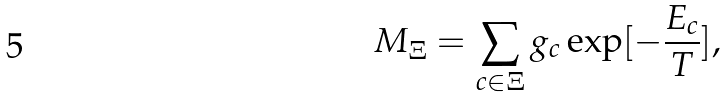<formula> <loc_0><loc_0><loc_500><loc_500>M _ { \Xi } = \sum _ { c \in \Xi } g _ { c } \exp [ - \frac { E _ { c } } { T } ] ,</formula> 